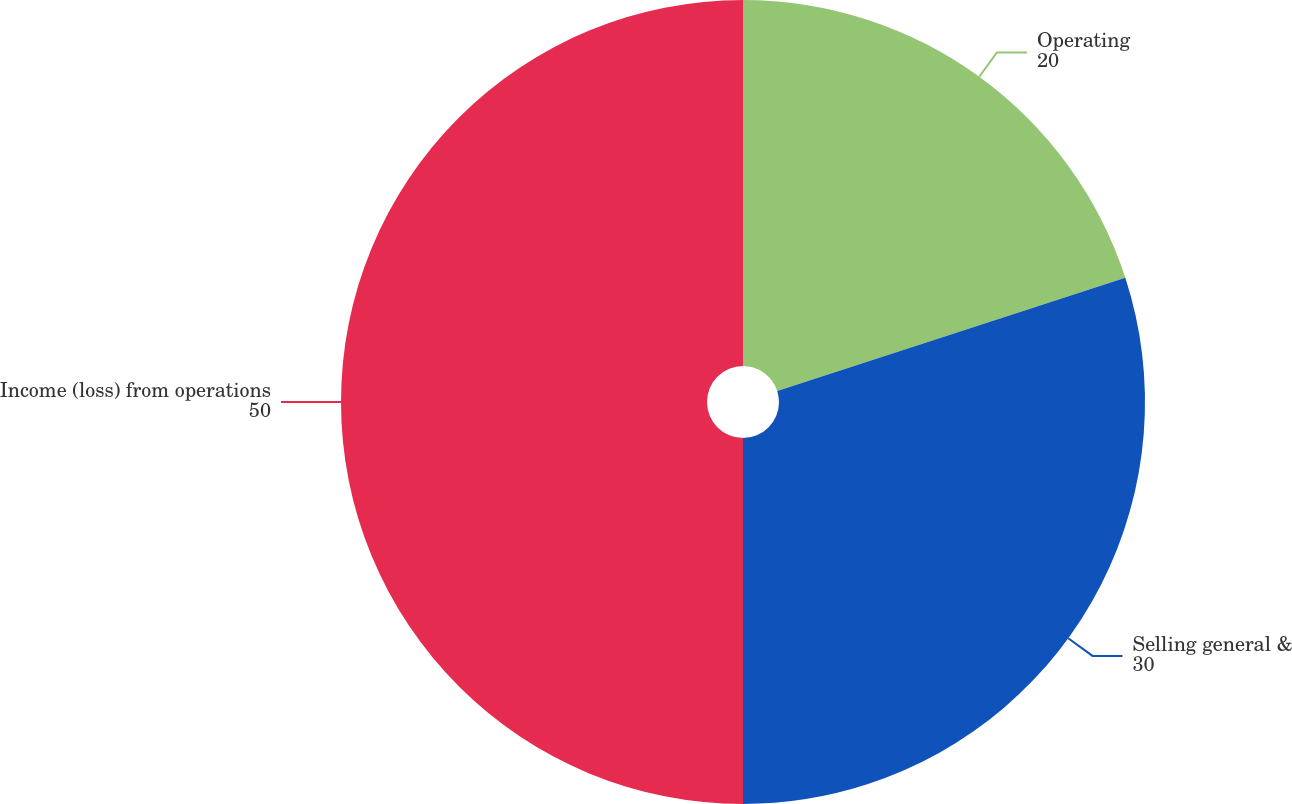Convert chart. <chart><loc_0><loc_0><loc_500><loc_500><pie_chart><fcel>Operating<fcel>Selling general &<fcel>Income (loss) from operations<nl><fcel>20.0%<fcel>30.0%<fcel>50.0%<nl></chart> 